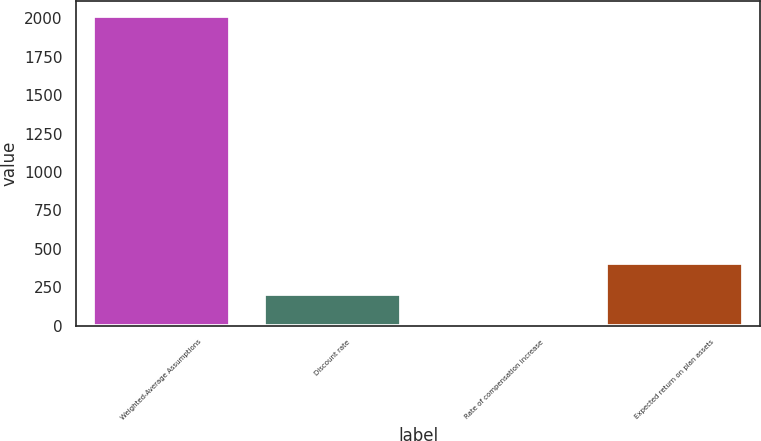Convert chart. <chart><loc_0><loc_0><loc_500><loc_500><bar_chart><fcel>Weighted-Average Assumptions<fcel>Discount rate<fcel>Rate of compensation increase<fcel>Expected return on plan assets<nl><fcel>2013<fcel>204.9<fcel>4<fcel>405.8<nl></chart> 